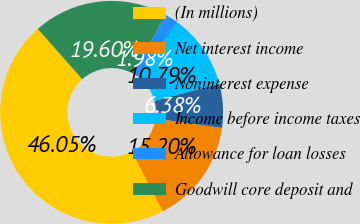Convert chart. <chart><loc_0><loc_0><loc_500><loc_500><pie_chart><fcel>(In millions)<fcel>Net interest income<fcel>Noninterest expense<fcel>Income before income taxes<fcel>Allowance for loan losses<fcel>Goodwill core deposit and<nl><fcel>46.05%<fcel>15.2%<fcel>6.38%<fcel>10.79%<fcel>1.98%<fcel>19.6%<nl></chart> 